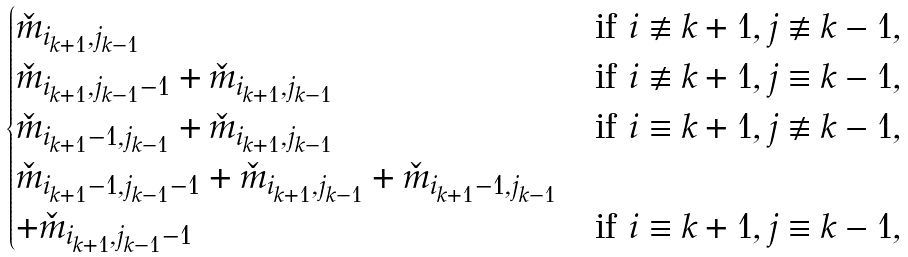<formula> <loc_0><loc_0><loc_500><loc_500>\begin{cases} \check { m } _ { i _ { k + 1 } , j _ { k - 1 } } & \text {if } i \not \equiv k + 1 , j \not \equiv k - 1 , \\ \check { m } _ { i _ { k + 1 } , j _ { k - 1 } - 1 } + \check { m } _ { i _ { k + 1 } , j _ { k - 1 } } & \text {if } i \not \equiv k + 1 , j \equiv k - 1 , \\ \check { m } _ { i _ { k + 1 } - 1 , j _ { k - 1 } } + \check { m } _ { i _ { k + 1 } , j _ { k - 1 } } & \text {if } i \equiv k + 1 , j \not \equiv k - 1 , \\ \check { m } _ { i _ { k + 1 } - 1 , j _ { k - 1 } - 1 } + \check { m } _ { i _ { k + 1 } , j _ { k - 1 } } + \check { m } _ { i _ { k + 1 } - 1 , j _ { k - 1 } } \\ + \check { m } _ { i _ { k + 1 } , j _ { k - 1 } - 1 } & \text {if } i \equiv k + 1 , j \equiv k - 1 , \end{cases}</formula> 